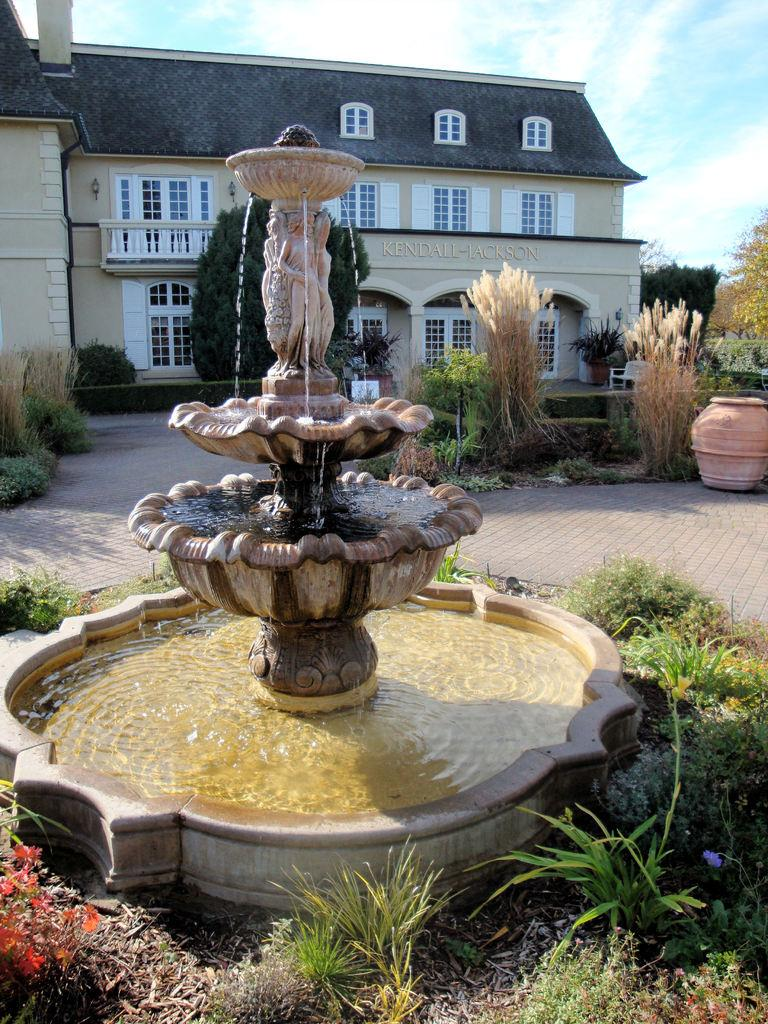What type of structure is visible in the image? There is a building in the image. What other natural elements can be seen in the image? There are trees and plants visible in the image. What type of water feature is present in the image? There is a water fountain in the image. How would you describe the sky in the image? The sky is blue and cloudy in the image. Can you tell me what type of pet the girl is holding in the image? There is no girl or pet present in the image. What type of weather is depicted in the image? The weather cannot be determined from the image, as only the sky's appearance is mentioned, which is blue and cloudy. 